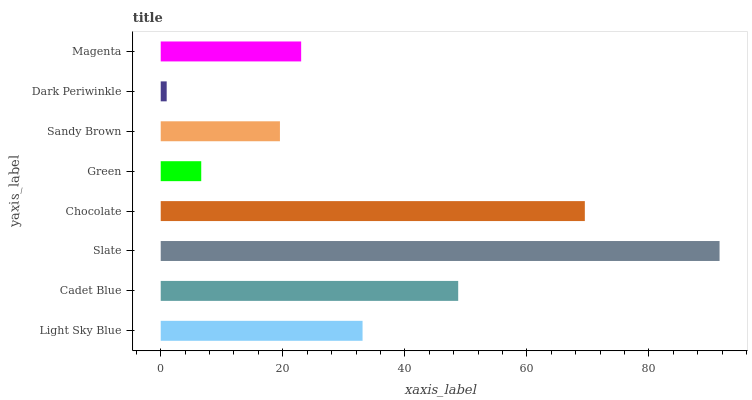Is Dark Periwinkle the minimum?
Answer yes or no. Yes. Is Slate the maximum?
Answer yes or no. Yes. Is Cadet Blue the minimum?
Answer yes or no. No. Is Cadet Blue the maximum?
Answer yes or no. No. Is Cadet Blue greater than Light Sky Blue?
Answer yes or no. Yes. Is Light Sky Blue less than Cadet Blue?
Answer yes or no. Yes. Is Light Sky Blue greater than Cadet Blue?
Answer yes or no. No. Is Cadet Blue less than Light Sky Blue?
Answer yes or no. No. Is Light Sky Blue the high median?
Answer yes or no. Yes. Is Magenta the low median?
Answer yes or no. Yes. Is Green the high median?
Answer yes or no. No. Is Sandy Brown the low median?
Answer yes or no. No. 